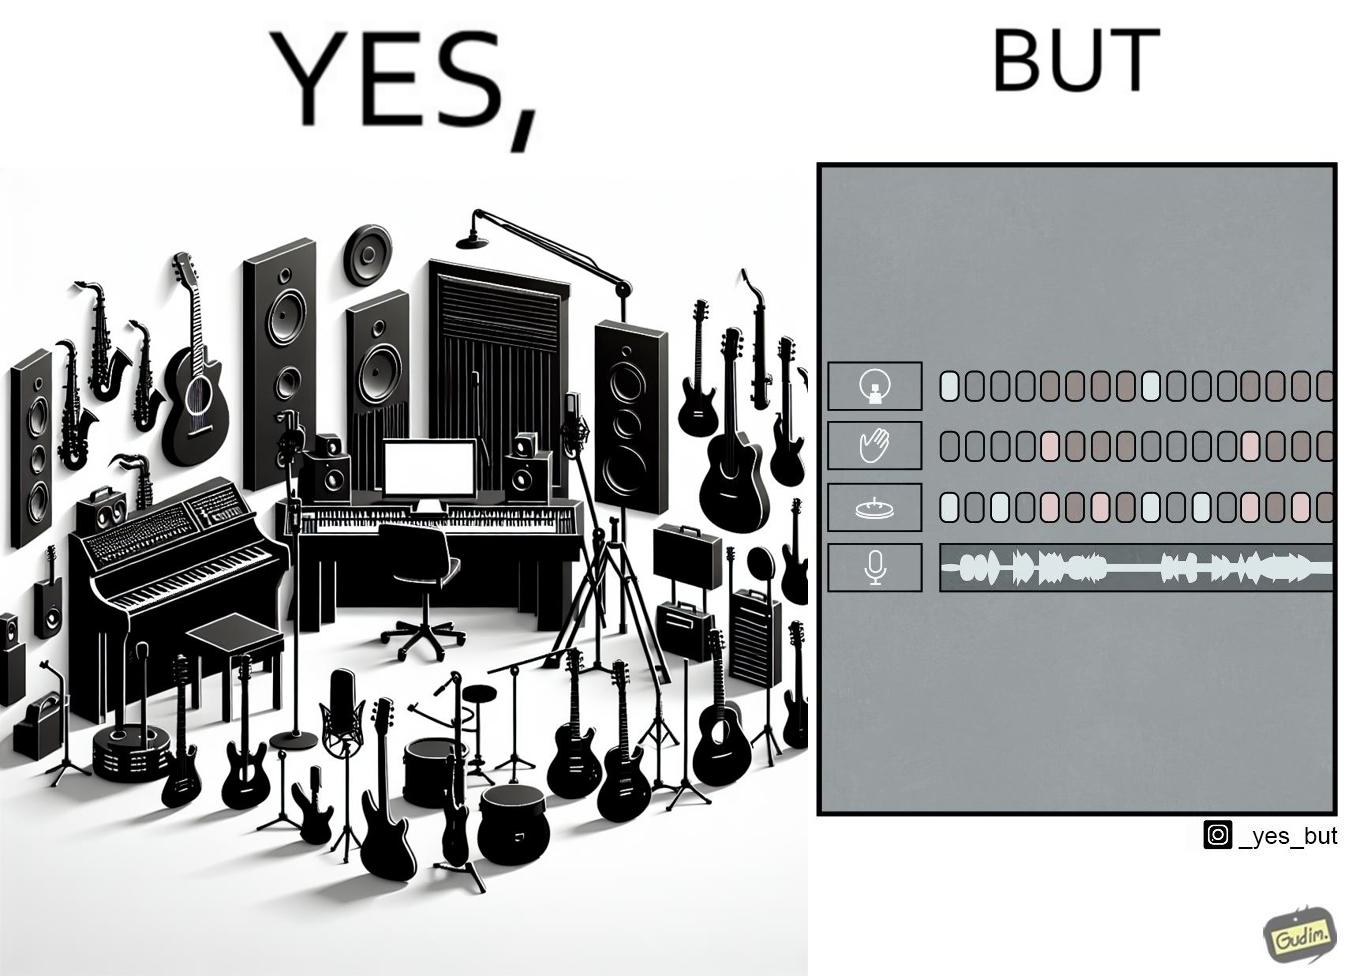Is this a satirical image? Yes, this image is satirical. 